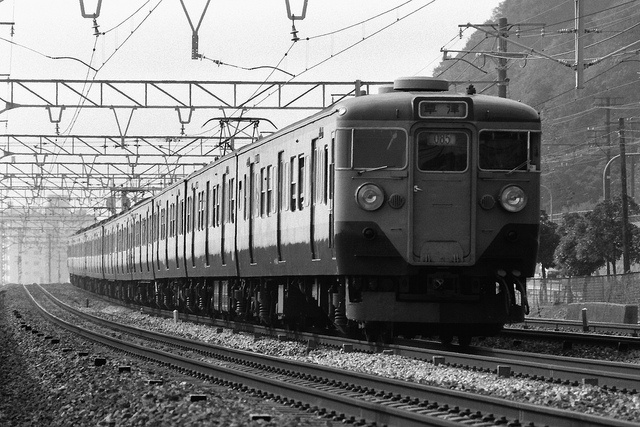Describe the objects in this image and their specific colors. I can see a train in darkgray, black, gray, and lightgray tones in this image. 